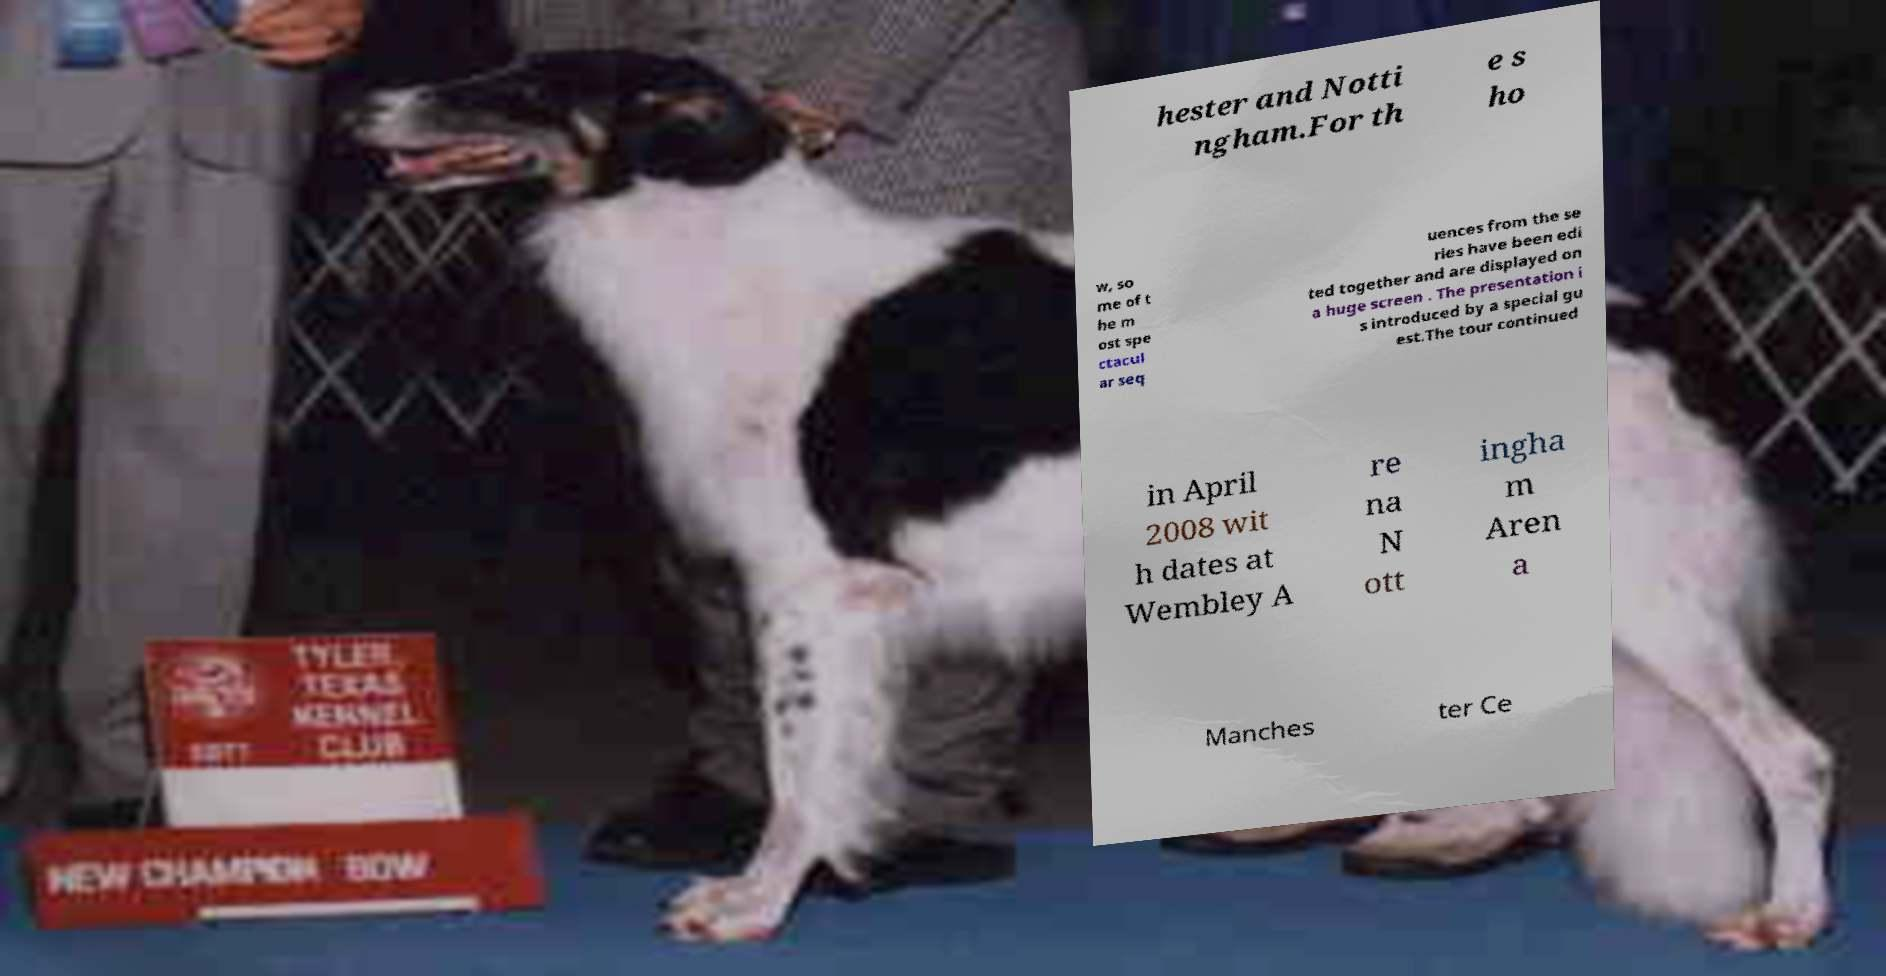Please identify and transcribe the text found in this image. hester and Notti ngham.For th e s ho w, so me of t he m ost spe ctacul ar seq uences from the se ries have been edi ted together and are displayed on a huge screen . The presentation i s introduced by a special gu est.The tour continued in April 2008 wit h dates at Wembley A re na N ott ingha m Aren a Manches ter Ce 